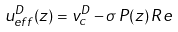Convert formula to latex. <formula><loc_0><loc_0><loc_500><loc_500>u _ { e f f } ^ { D } ( z ) = v _ { c } ^ { D } - \sigma \, P ( z ) \, R e</formula> 